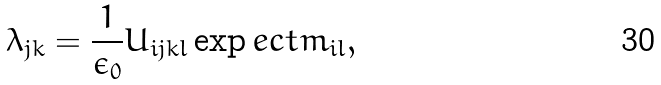Convert formula to latex. <formula><loc_0><loc_0><loc_500><loc_500>\lambda _ { j k } = \frac { 1 } { \epsilon _ { 0 } } U _ { i j k l } \exp e c t { m _ { i l } } ,</formula> 